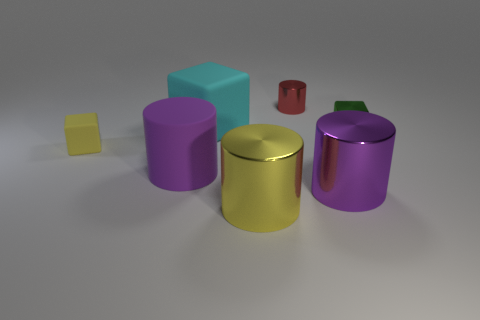Subtract all purple cylinders. How many were subtracted if there are1purple cylinders left? 1 Subtract all brown blocks. Subtract all yellow cylinders. How many blocks are left? 3 Add 3 big yellow rubber objects. How many objects exist? 10 Subtract all cubes. How many objects are left? 4 Add 2 large purple objects. How many large purple objects are left? 4 Add 7 big purple rubber things. How many big purple rubber things exist? 8 Subtract 0 green cylinders. How many objects are left? 7 Subtract all large yellow shiny cylinders. Subtract all small rubber blocks. How many objects are left? 5 